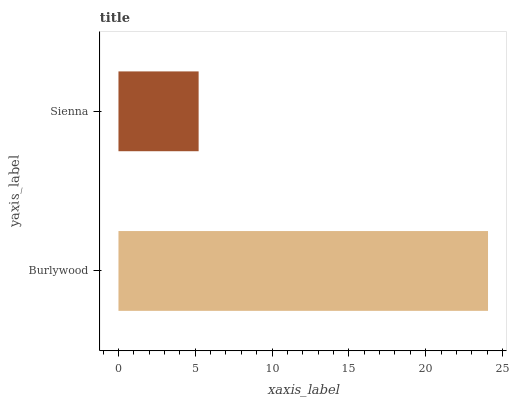Is Sienna the minimum?
Answer yes or no. Yes. Is Burlywood the maximum?
Answer yes or no. Yes. Is Sienna the maximum?
Answer yes or no. No. Is Burlywood greater than Sienna?
Answer yes or no. Yes. Is Sienna less than Burlywood?
Answer yes or no. Yes. Is Sienna greater than Burlywood?
Answer yes or no. No. Is Burlywood less than Sienna?
Answer yes or no. No. Is Burlywood the high median?
Answer yes or no. Yes. Is Sienna the low median?
Answer yes or no. Yes. Is Sienna the high median?
Answer yes or no. No. Is Burlywood the low median?
Answer yes or no. No. 